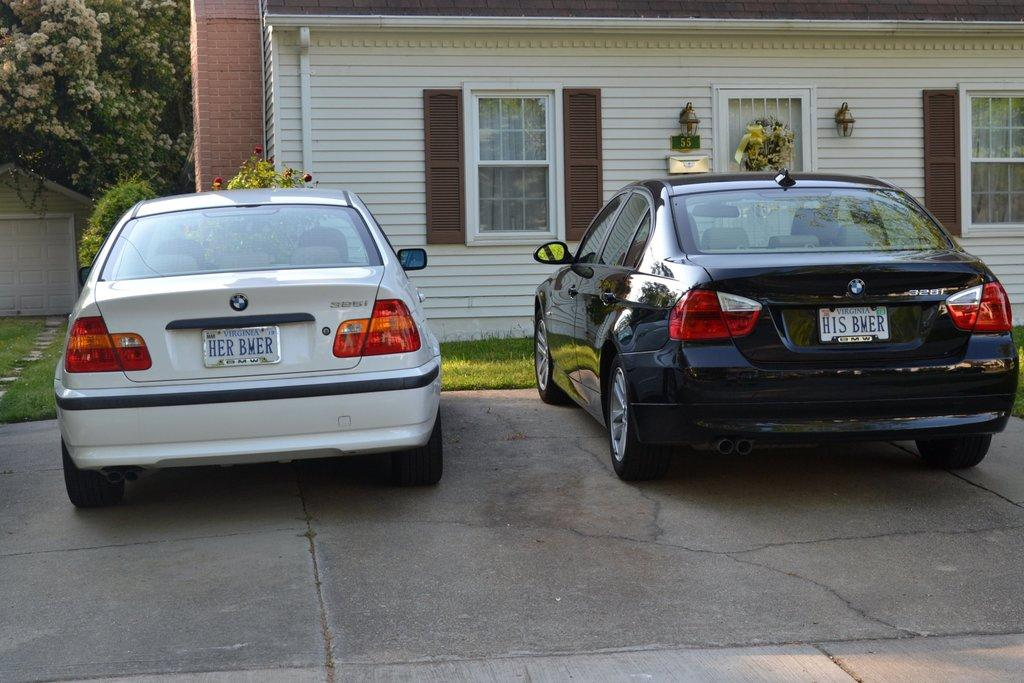<image>
Describe the image concisely. A black and a white BMW are parked side by side, in front of a house. 